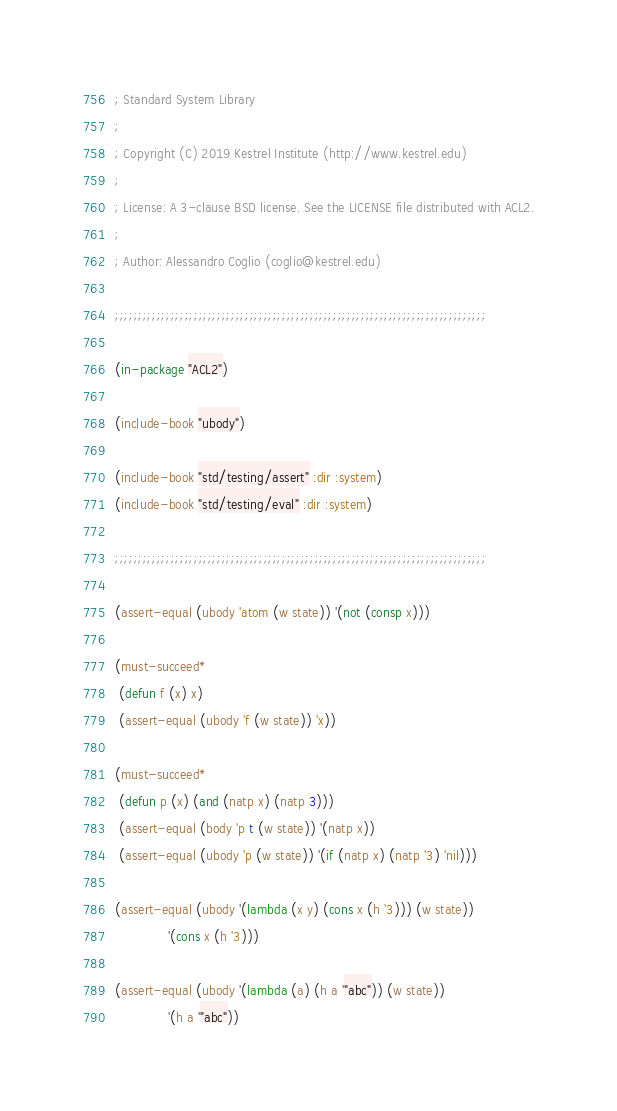Convert code to text. <code><loc_0><loc_0><loc_500><loc_500><_Lisp_>; Standard System Library
;
; Copyright (C) 2019 Kestrel Institute (http://www.kestrel.edu)
;
; License: A 3-clause BSD license. See the LICENSE file distributed with ACL2.
;
; Author: Alessandro Coglio (coglio@kestrel.edu)

;;;;;;;;;;;;;;;;;;;;;;;;;;;;;;;;;;;;;;;;;;;;;;;;;;;;;;;;;;;;;;;;;;;;;;;;;;;;;;;;

(in-package "ACL2")

(include-book "ubody")

(include-book "std/testing/assert" :dir :system)
(include-book "std/testing/eval" :dir :system)

;;;;;;;;;;;;;;;;;;;;;;;;;;;;;;;;;;;;;;;;;;;;;;;;;;;;;;;;;;;;;;;;;;;;;;;;;;;;;;;;

(assert-equal (ubody 'atom (w state)) '(not (consp x)))

(must-succeed*
 (defun f (x) x)
 (assert-equal (ubody 'f (w state)) 'x))

(must-succeed*
 (defun p (x) (and (natp x) (natp 3)))
 (assert-equal (body 'p t (w state)) '(natp x))
 (assert-equal (ubody 'p (w state)) '(if (natp x) (natp '3) 'nil)))

(assert-equal (ubody '(lambda (x y) (cons x (h '3))) (w state))
              '(cons x (h '3)))

(assert-equal (ubody '(lambda (a) (h a '"abc")) (w state))
              '(h a '"abc"))
</code> 